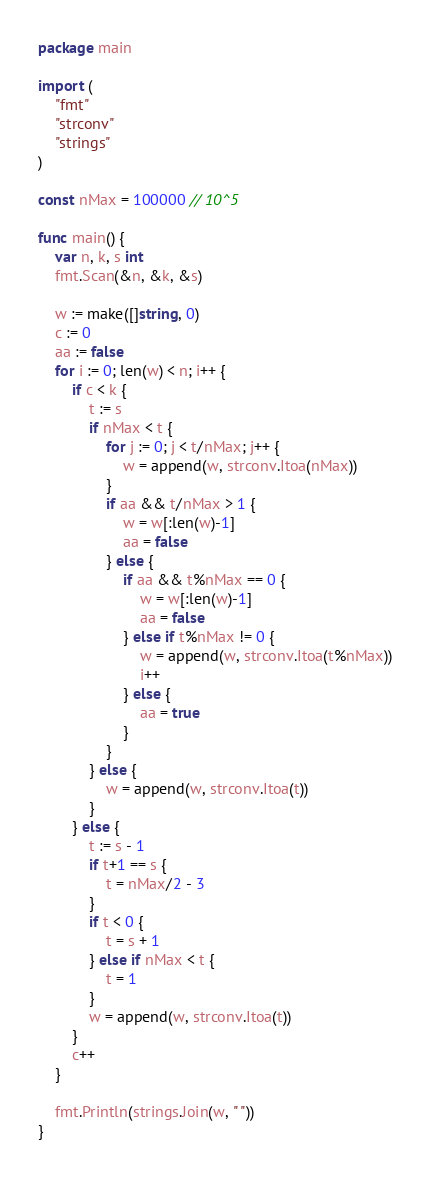<code> <loc_0><loc_0><loc_500><loc_500><_Go_>package main

import (
	"fmt"
	"strconv"
	"strings"
)

const nMax = 100000 // 10^5

func main() {
	var n, k, s int
	fmt.Scan(&n, &k, &s)

	w := make([]string, 0)
	c := 0
	aa := false
	for i := 0; len(w) < n; i++ {
		if c < k {
			t := s
			if nMax < t {
				for j := 0; j < t/nMax; j++ {
					w = append(w, strconv.Itoa(nMax))
				}
				if aa && t/nMax > 1 {
					w = w[:len(w)-1]
					aa = false
				} else {
					if aa && t%nMax == 0 {
						w = w[:len(w)-1]
						aa = false
					} else if t%nMax != 0 {
						w = append(w, strconv.Itoa(t%nMax))
						i++
					} else {
						aa = true
					}
				}
			} else {
				w = append(w, strconv.Itoa(t))
			}
		} else {
			t := s - 1
			if t+1 == s {
				t = nMax/2 - 3
			}
			if t < 0 {
				t = s + 1
			} else if nMax < t {
				t = 1
			}
			w = append(w, strconv.Itoa(t))
		}
		c++
	}

	fmt.Println(strings.Join(w, " "))
}
</code> 